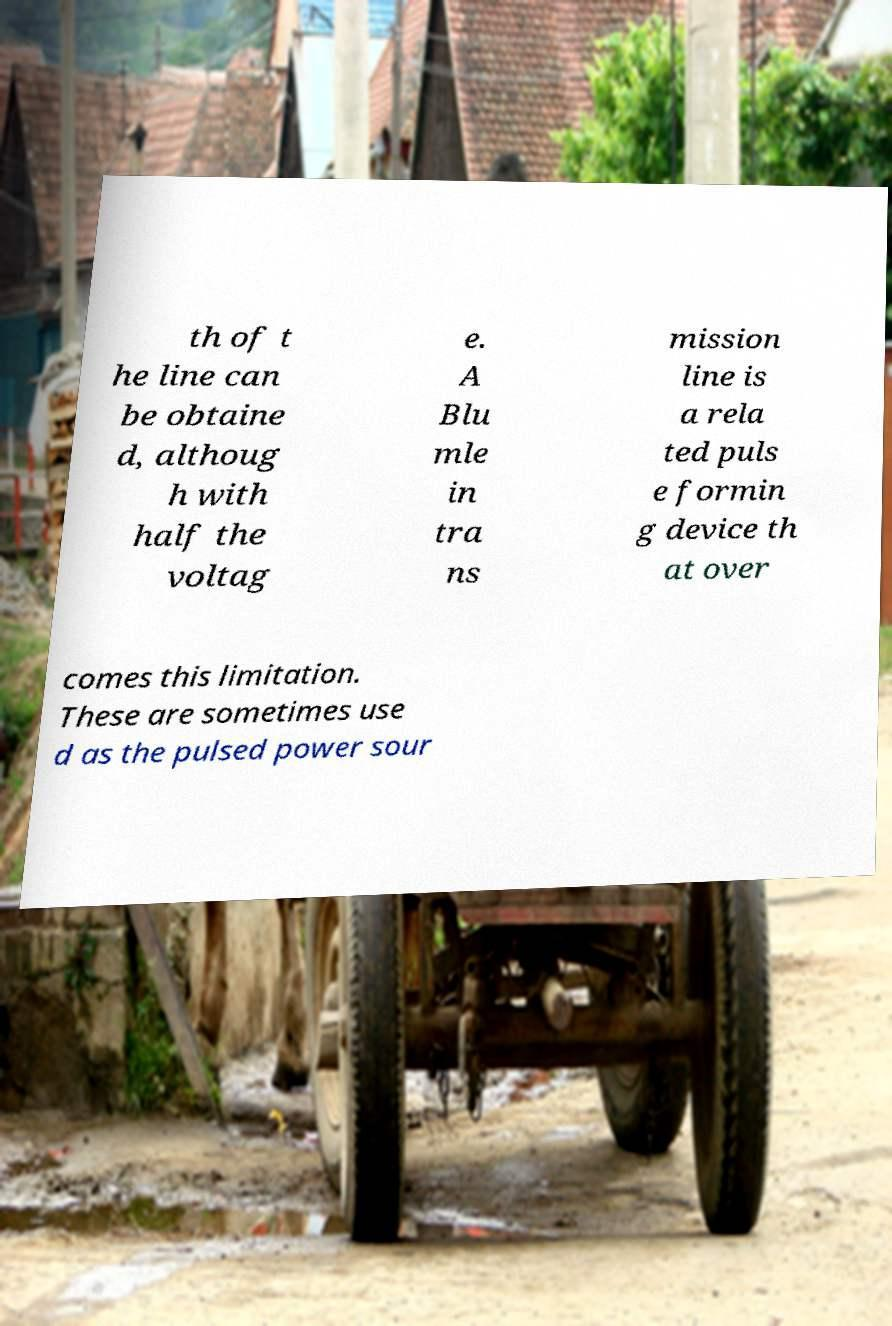Please identify and transcribe the text found in this image. th of t he line can be obtaine d, althoug h with half the voltag e. A Blu mle in tra ns mission line is a rela ted puls e formin g device th at over comes this limitation. These are sometimes use d as the pulsed power sour 